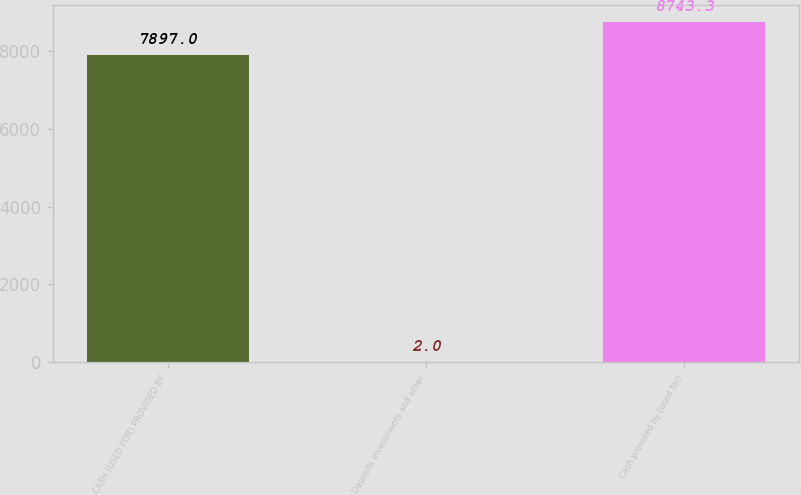Convert chart to OTSL. <chart><loc_0><loc_0><loc_500><loc_500><bar_chart><fcel>CASH (USED FOR) PROVIDED BY<fcel>Deposits investments and other<fcel>Cash provided by (used for)<nl><fcel>7897<fcel>2<fcel>8743.3<nl></chart> 